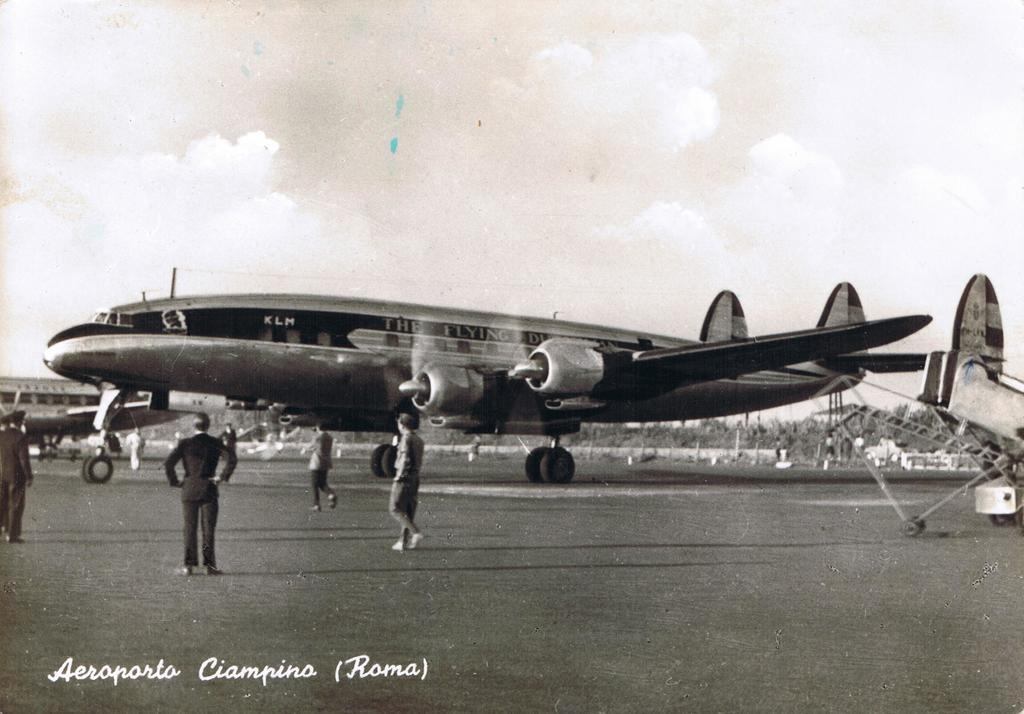<image>
Render a clear and concise summary of the photo. A vintage picture of an old airplane can be seen at Aeroporta Ciampina in Roma 